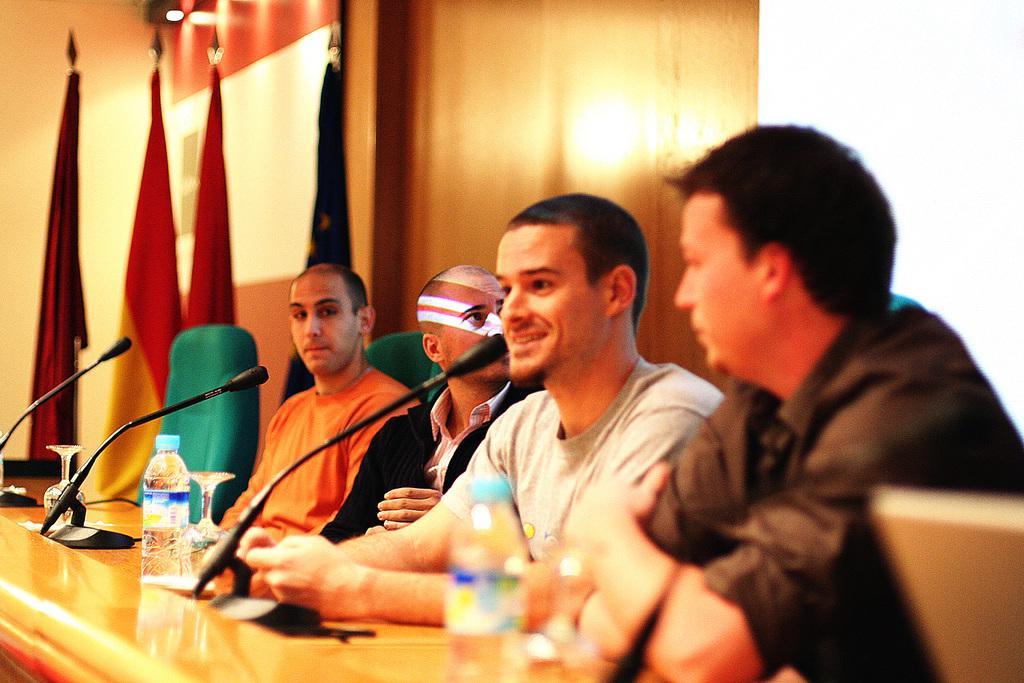Please provide a concise description of this image. This picture is clicked inside. On the right with we can see the group of men sitting on the chairs. In the center there is a table on the top of which microphones are attached and we can see the glasses and bottles are placed on the top of the table. In the background there is a green color chair, flags, wall, lights and a white color board. 